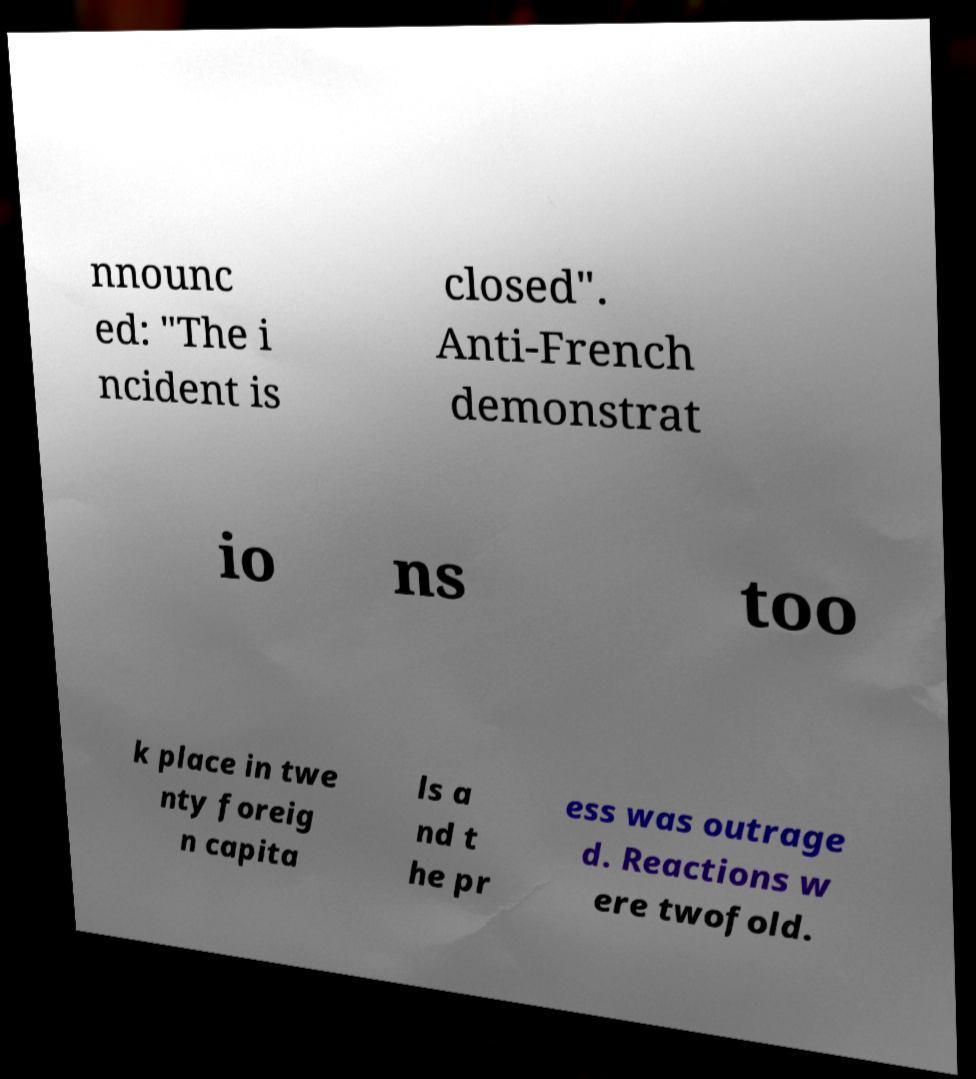What messages or text are displayed in this image? I need them in a readable, typed format. nnounc ed: "The i ncident is closed". Anti-French demonstrat io ns too k place in twe nty foreig n capita ls a nd t he pr ess was outrage d. Reactions w ere twofold. 